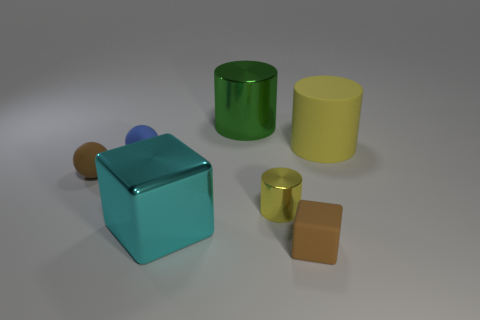Subtract all metallic cylinders. How many cylinders are left? 1 Subtract 1 cylinders. How many cylinders are left? 2 Add 2 large green cylinders. How many objects exist? 9 Subtract all green cylinders. How many cylinders are left? 2 Add 6 small brown blocks. How many small brown blocks exist? 7 Subtract 0 purple cylinders. How many objects are left? 7 Subtract all balls. How many objects are left? 5 Subtract all cyan balls. Subtract all gray cylinders. How many balls are left? 2 Subtract all yellow cylinders. How many red blocks are left? 0 Subtract all green metal blocks. Subtract all large yellow cylinders. How many objects are left? 6 